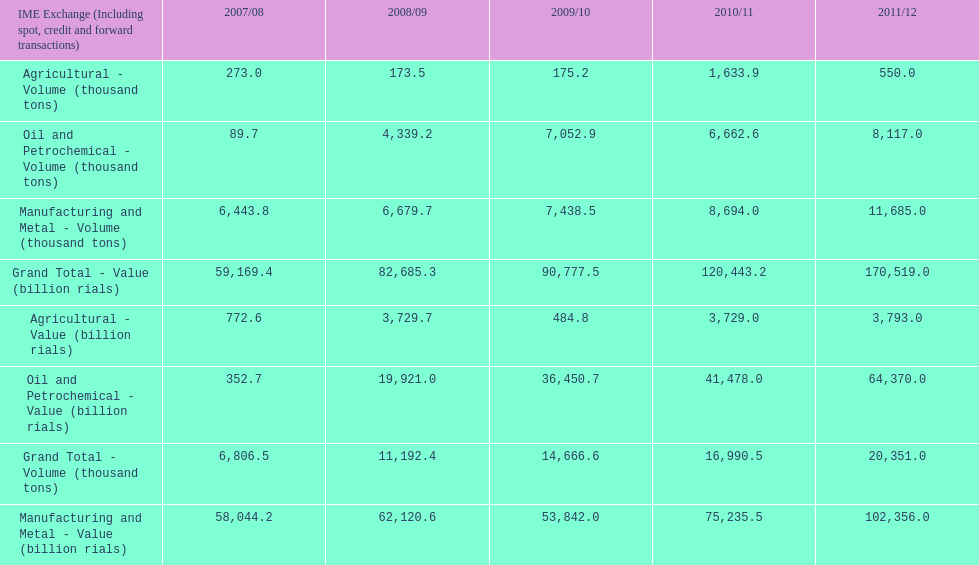Did 2010/11 or 2011/12 make more in grand total value? 2011/12. 